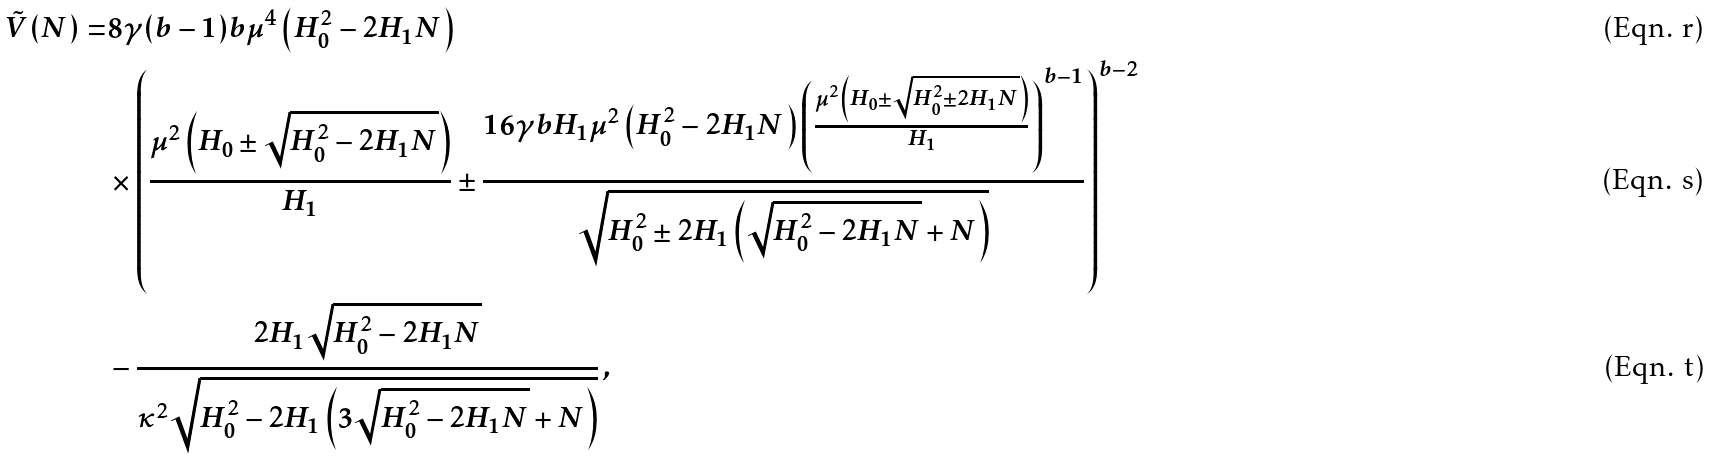<formula> <loc_0><loc_0><loc_500><loc_500>\tilde { V } ( N ) = & 8 \gamma ( b - 1 ) b \mu ^ { 4 } \left ( H _ { 0 } ^ { 2 } - 2 H _ { 1 } N \right ) \\ & \times \left ( \frac { \mu ^ { 2 } \left ( H _ { 0 } \pm \sqrt { H _ { 0 } ^ { 2 } - 2 H _ { 1 } N } \right ) } { H _ { 1 } } \pm \frac { 1 6 \gamma b H _ { 1 } \mu ^ { 2 } \left ( H _ { 0 } ^ { 2 } - 2 H _ { 1 } N \right ) \left ( \frac { \mu ^ { 2 } \left ( H _ { 0 } \pm \sqrt { H _ { 0 } ^ { 2 } \pm 2 H _ { 1 } N } \right ) } { H _ { 1 } } \right ) ^ { b - 1 } } { \sqrt { H _ { 0 } ^ { 2 } \pm 2 H _ { 1 } \left ( \sqrt { H _ { 0 } ^ { 2 } - 2 H _ { 1 } N } + N \right ) } } \right ) ^ { b - 2 } \\ & - \frac { 2 H _ { 1 } \sqrt { H _ { 0 } ^ { 2 } - 2 H _ { 1 } N } } { \kappa ^ { 2 } \sqrt { H _ { 0 } ^ { 2 } - 2 H _ { 1 } \left ( 3 \sqrt { H _ { 0 } ^ { 2 } - 2 H _ { 1 } N } + N \right ) } } \, ,</formula> 